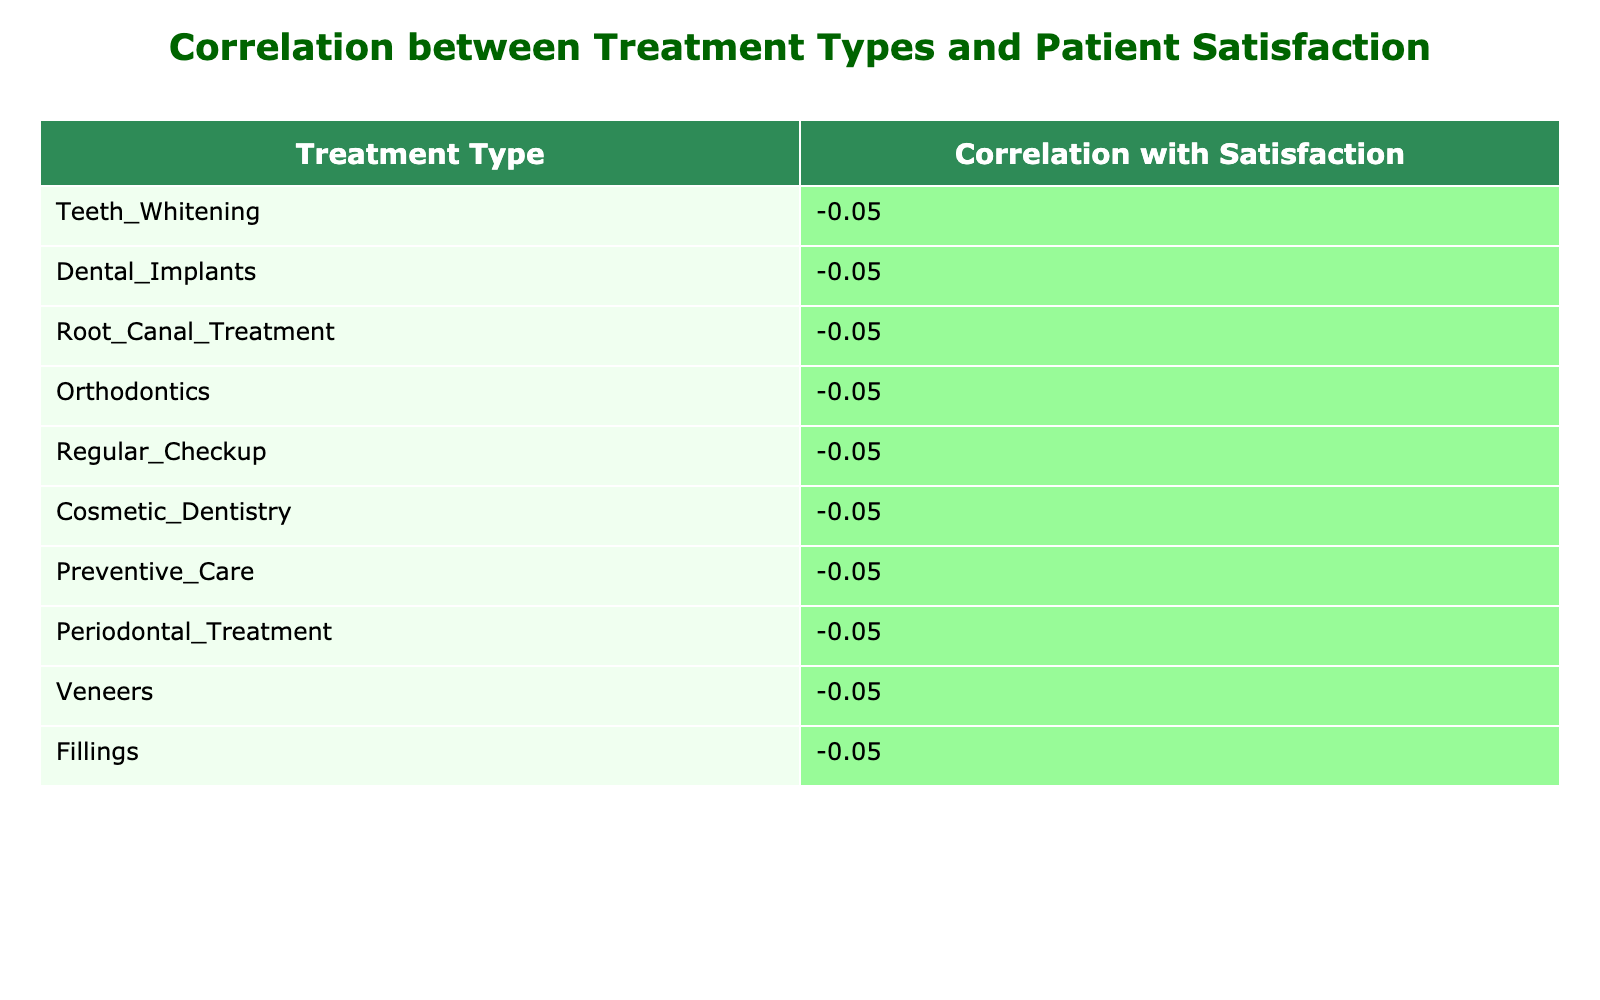What is the Patient Satisfaction Score for Cosmetic Dentistry? The score for Cosmetic Dentistry is listed directly in the table under the corresponding treatment type. It shows that the Patient Satisfaction Score for Cosmetic Dentistry is 94.
Answer: 94 Which treatment type has the highest Patient Satisfaction Score? By examining the table, we can see which treatment has the highest score. The treatment type with the highest score is Veneers, which has a score of 95.
Answer: Veneers What is the average Patient Satisfaction Score for all treatments? To find the average, sum all the Patient Satisfaction Scores: 88 + 92 + 75 + 90 + 85 + 94 + 87 + 78 + 95 + 82 =  916. Then, divide by the number of treatments (10): 916/10 = 91.6.
Answer: 91.6 Are there any treatments with a Patient Satisfaction Score below 80? By reviewing the table data, we can identify if any scores are below 80. The treatments Root Canal Treatment (75) and Periodontal Treatment (78) both have scores below 80, which confirms the statement is true.
Answer: Yes What is the difference in Patient Satisfaction Scores between the highest and lowest rated treatments? The highest rating found in the table is for Veneers (95) and the lowest for Root Canal Treatment (75). Calculating the difference: 95 - 75 = 20, shows the gap in satisfaction ratings.
Answer: 20 Which treatment types have a Patient Satisfaction Score above 85? We look through the Patient Satisfaction Scores and list those over 85. The treatments with scores above 85 are Cosmetic Dentistry (94), Veneers (95), Dental Implants (92), Orthodontics (90), and Preventive Care (87). This confirms there are multiple treatments in this category.
Answer: 5 treatments Is the Patient Satisfaction Score for Regular Checkup greater than that for Fillings? The scores are 85 for Regular Checkup and 82 for Fillings. Comparing the two, we find that 85 > 82, confirming this statement as true.
Answer: Yes What is the median Patient Satisfaction Score of all treatments? First, we list all the scores in ascending order: 75, 78, 82, 85, 87, 88, 90, 92, 94, 95. Since there are 10 scores, the median will be the average of the 5th and 6th scores: (87 + 88)/2 = 87.5.
Answer: 87.5 